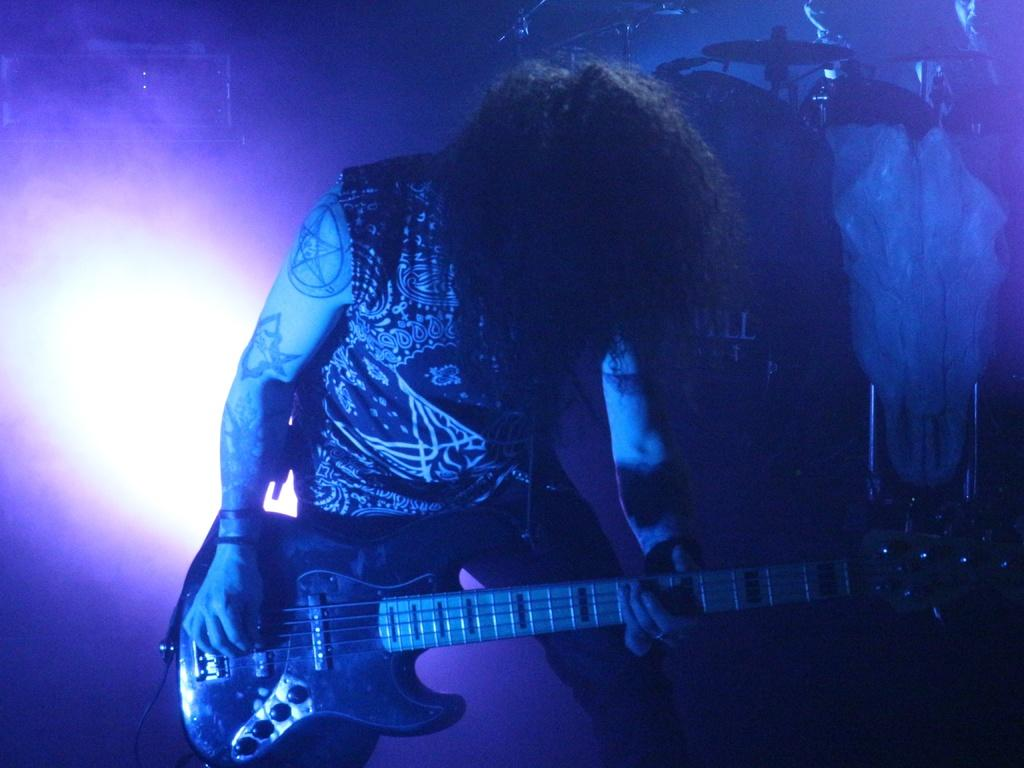What is the person in the image doing? The person is playing a guitar. What musical instrument can be seen in the background of the image? There are drums in the background of the image. How many spiders are crawling on the person's chin in the image? There are no spiders present in the image, and the person's chin is not visible. 